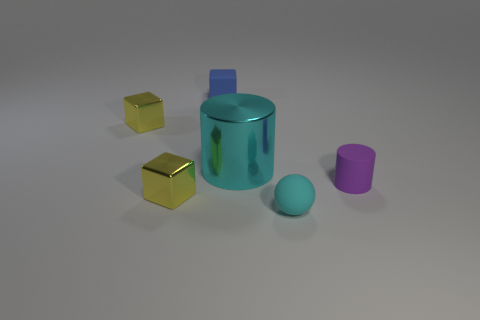Subtract all small yellow cubes. How many cubes are left? 1 Subtract all cylinders. How many objects are left? 4 Add 3 yellow metallic things. How many yellow metallic things exist? 5 Add 1 tiny purple rubber cylinders. How many objects exist? 7 Subtract all cyan cylinders. How many cylinders are left? 1 Subtract 0 cyan cubes. How many objects are left? 6 Subtract 2 blocks. How many blocks are left? 1 Subtract all yellow blocks. Subtract all brown cylinders. How many blocks are left? 1 Subtract all green blocks. How many purple cylinders are left? 1 Subtract all small blue spheres. Subtract all blue matte blocks. How many objects are left? 5 